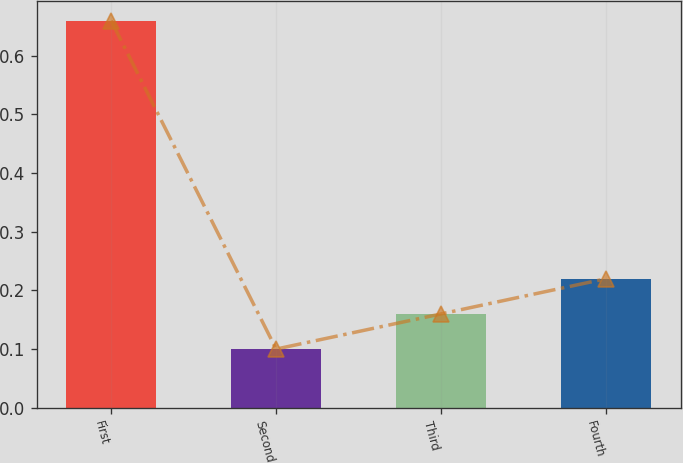Convert chart. <chart><loc_0><loc_0><loc_500><loc_500><bar_chart><fcel>First<fcel>Second<fcel>Third<fcel>Fourth<nl><fcel>0.66<fcel>0.1<fcel>0.16<fcel>0.22<nl></chart> 